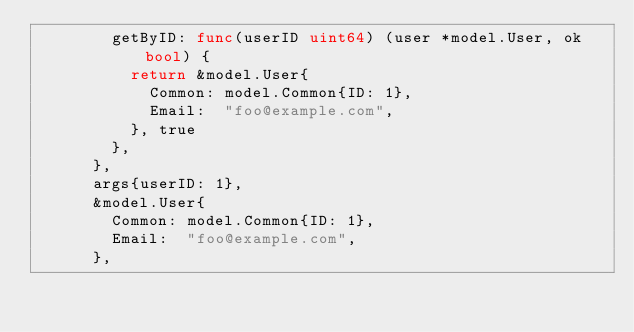Convert code to text. <code><loc_0><loc_0><loc_500><loc_500><_Go_>				getByID: func(userID uint64) (user *model.User, ok bool) {
					return &model.User{
						Common: model.Common{ID: 1},
						Email:  "foo@example.com",
					}, true
				},
			},
			args{userID: 1},
			&model.User{
				Common: model.Common{ID: 1},
				Email:  "foo@example.com",
			},</code> 